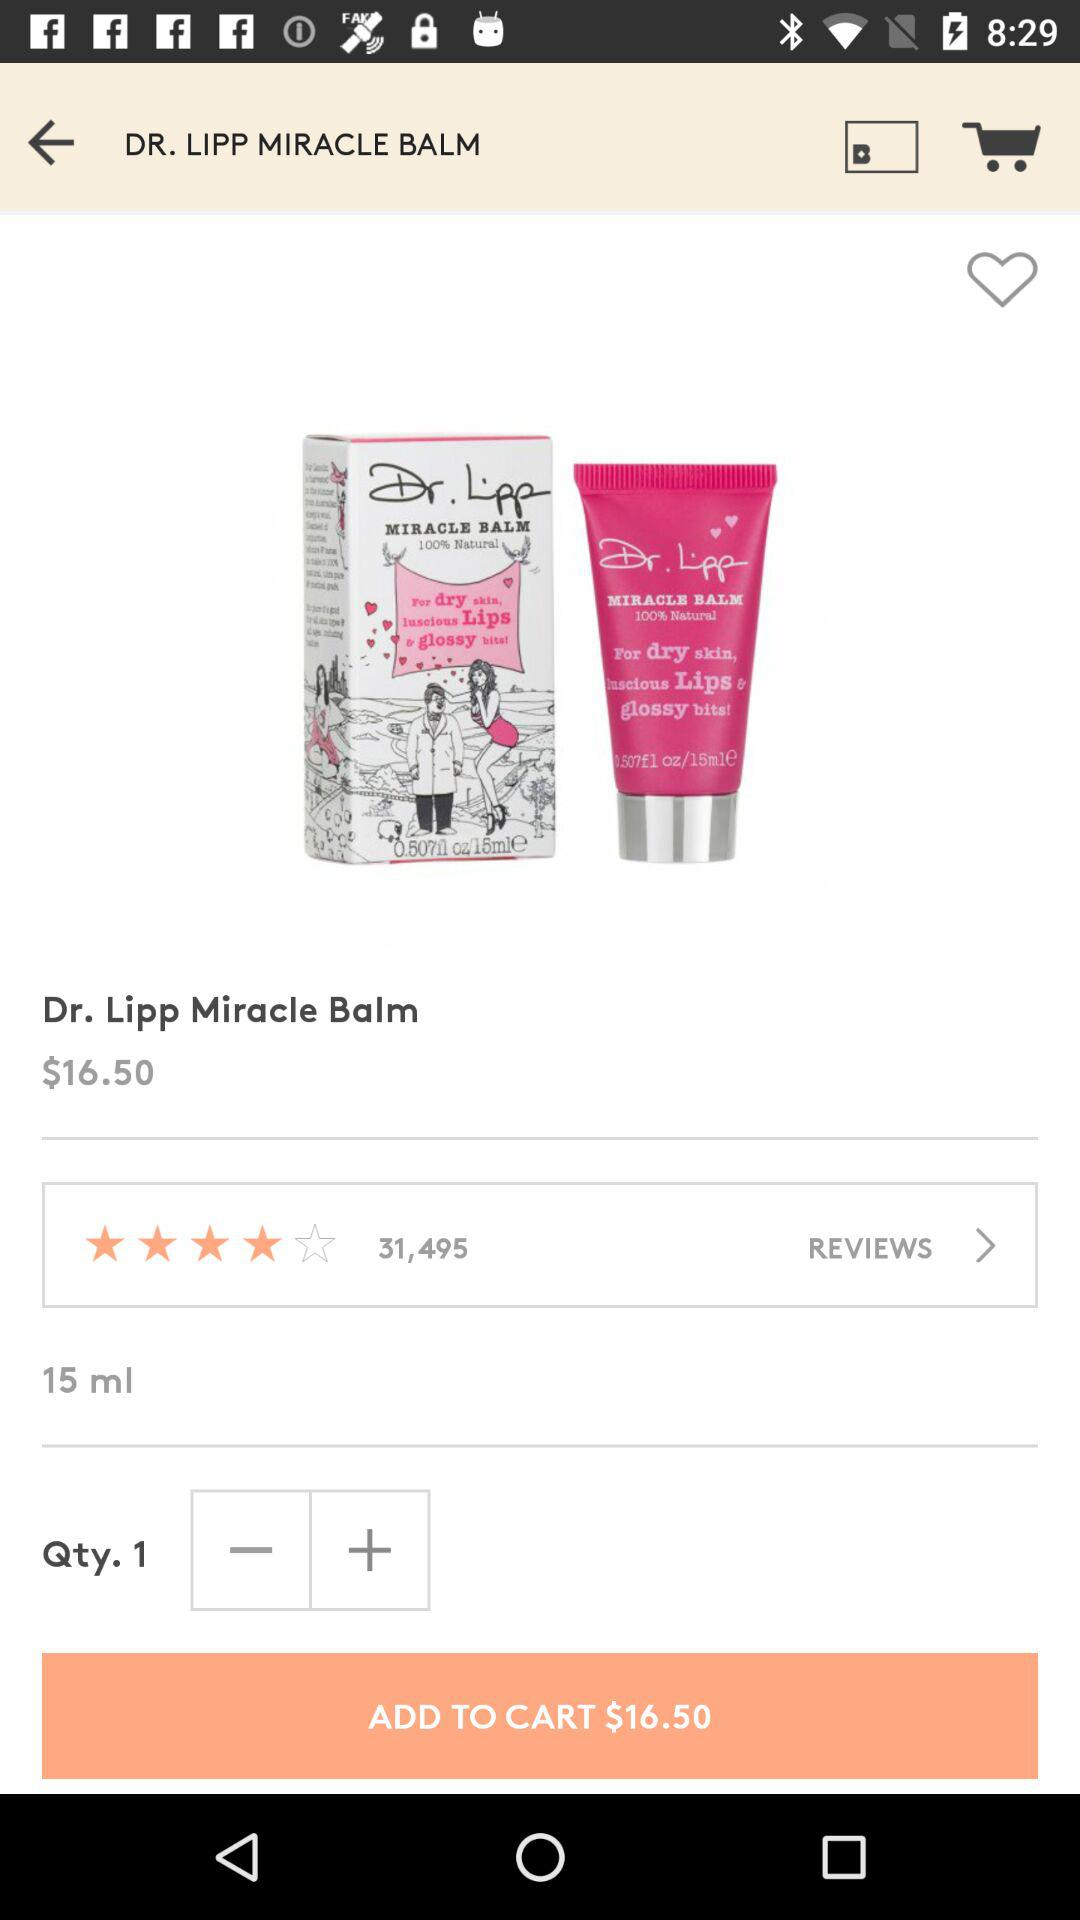What is the quantity of lip balm? The quantity is 1. 